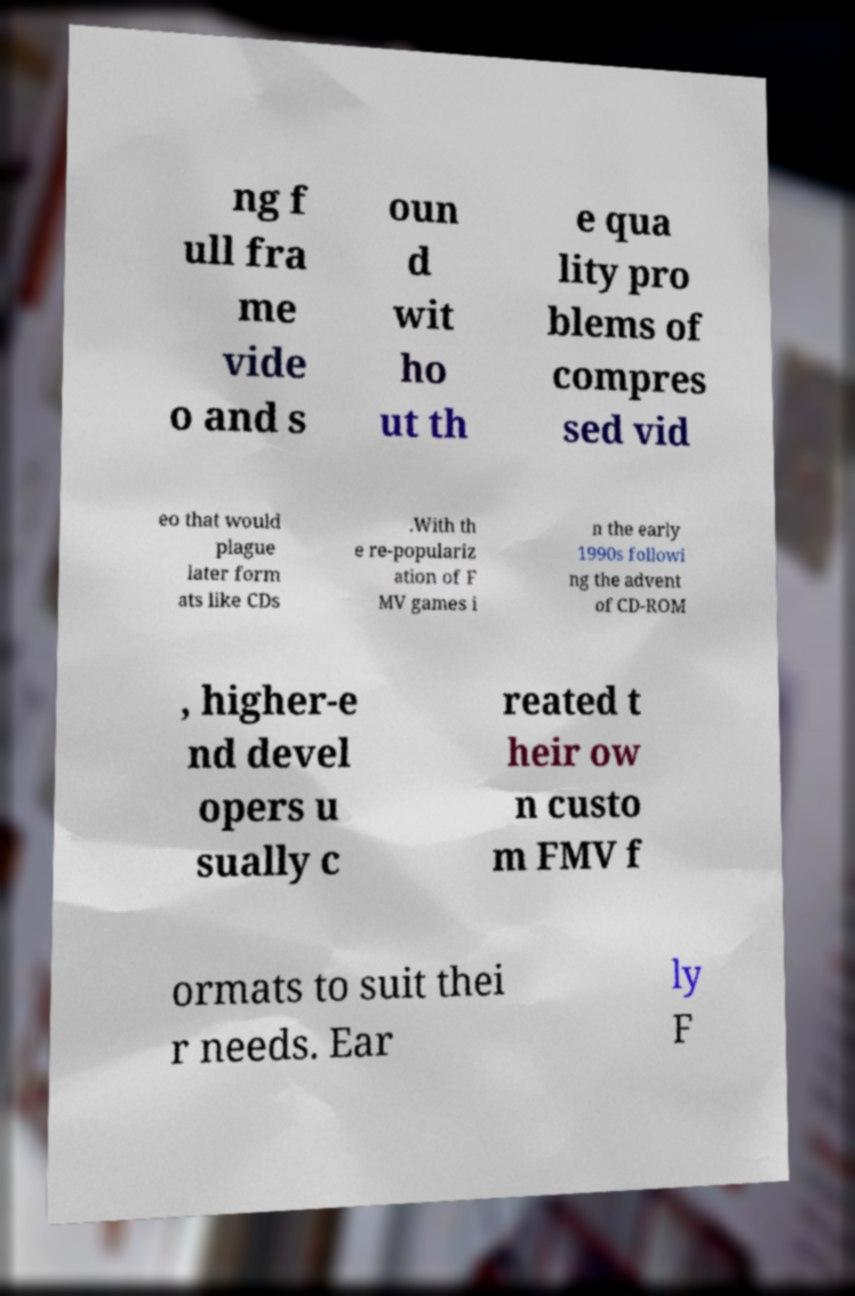Could you assist in decoding the text presented in this image and type it out clearly? ng f ull fra me vide o and s oun d wit ho ut th e qua lity pro blems of compres sed vid eo that would plague later form ats like CDs .With th e re-populariz ation of F MV games i n the early 1990s followi ng the advent of CD-ROM , higher-e nd devel opers u sually c reated t heir ow n custo m FMV f ormats to suit thei r needs. Ear ly F 